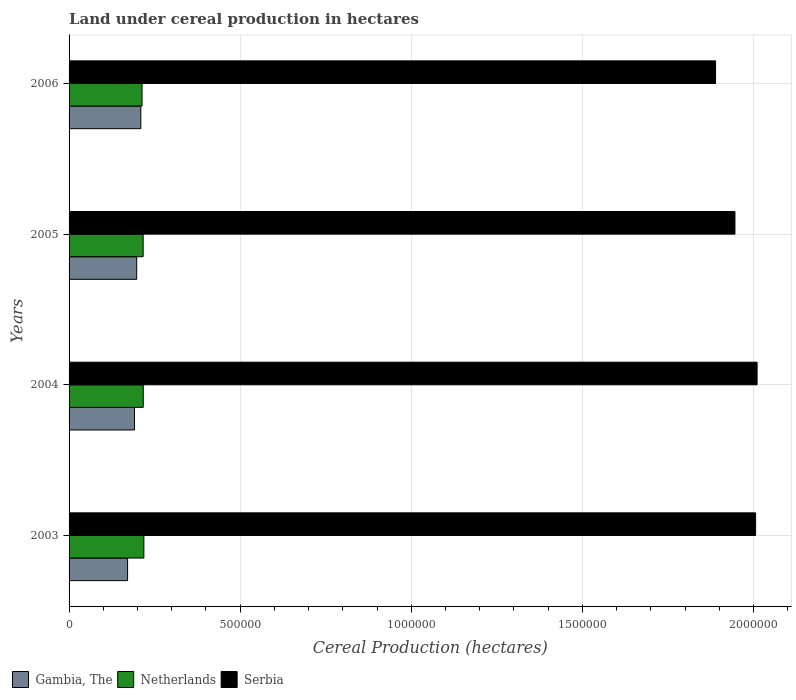Are the number of bars on each tick of the Y-axis equal?
Offer a terse response. Yes. What is the label of the 4th group of bars from the top?
Keep it short and to the point. 2003. What is the land under cereal production in Gambia, The in 2005?
Your response must be concise. 1.98e+05. Across all years, what is the maximum land under cereal production in Netherlands?
Offer a terse response. 2.19e+05. Across all years, what is the minimum land under cereal production in Gambia, The?
Your answer should be compact. 1.71e+05. In which year was the land under cereal production in Serbia maximum?
Offer a terse response. 2004. What is the total land under cereal production in Gambia, The in the graph?
Offer a very short reply. 7.70e+05. What is the difference between the land under cereal production in Netherlands in 2003 and that in 2006?
Ensure brevity in your answer.  5378. What is the difference between the land under cereal production in Netherlands in 2006 and the land under cereal production in Serbia in 2005?
Provide a succinct answer. -1.73e+06. What is the average land under cereal production in Serbia per year?
Give a very brief answer. 1.96e+06. In the year 2004, what is the difference between the land under cereal production in Netherlands and land under cereal production in Serbia?
Your answer should be very brief. -1.79e+06. What is the ratio of the land under cereal production in Gambia, The in 2003 to that in 2006?
Make the answer very short. 0.82. Is the land under cereal production in Serbia in 2003 less than that in 2005?
Keep it short and to the point. No. What is the difference between the highest and the second highest land under cereal production in Gambia, The?
Provide a short and direct response. 1.21e+04. What is the difference between the highest and the lowest land under cereal production in Gambia, The?
Ensure brevity in your answer.  3.88e+04. In how many years, is the land under cereal production in Netherlands greater than the average land under cereal production in Netherlands taken over all years?
Provide a short and direct response. 3. Is the sum of the land under cereal production in Netherlands in 2003 and 2005 greater than the maximum land under cereal production in Gambia, The across all years?
Keep it short and to the point. Yes. What does the 3rd bar from the top in 2005 represents?
Provide a succinct answer. Gambia, The. What does the 3rd bar from the bottom in 2006 represents?
Your response must be concise. Serbia. How many years are there in the graph?
Your answer should be very brief. 4. What is the difference between two consecutive major ticks on the X-axis?
Give a very brief answer. 5.00e+05. Does the graph contain grids?
Offer a terse response. Yes. Where does the legend appear in the graph?
Offer a very short reply. Bottom left. What is the title of the graph?
Provide a succinct answer. Land under cereal production in hectares. Does "Colombia" appear as one of the legend labels in the graph?
Keep it short and to the point. No. What is the label or title of the X-axis?
Ensure brevity in your answer.  Cereal Production (hectares). What is the Cereal Production (hectares) of Gambia, The in 2003?
Provide a short and direct response. 1.71e+05. What is the Cereal Production (hectares) of Netherlands in 2003?
Provide a short and direct response. 2.19e+05. What is the Cereal Production (hectares) of Serbia in 2003?
Provide a short and direct response. 2.01e+06. What is the Cereal Production (hectares) in Gambia, The in 2004?
Offer a terse response. 1.91e+05. What is the Cereal Production (hectares) of Netherlands in 2004?
Your answer should be compact. 2.17e+05. What is the Cereal Production (hectares) in Serbia in 2004?
Your answer should be compact. 2.01e+06. What is the Cereal Production (hectares) of Gambia, The in 2005?
Your answer should be compact. 1.98e+05. What is the Cereal Production (hectares) in Netherlands in 2005?
Provide a succinct answer. 2.16e+05. What is the Cereal Production (hectares) in Serbia in 2005?
Your answer should be compact. 1.95e+06. What is the Cereal Production (hectares) of Gambia, The in 2006?
Ensure brevity in your answer.  2.10e+05. What is the Cereal Production (hectares) of Netherlands in 2006?
Provide a short and direct response. 2.13e+05. What is the Cereal Production (hectares) in Serbia in 2006?
Provide a short and direct response. 1.89e+06. Across all years, what is the maximum Cereal Production (hectares) of Gambia, The?
Provide a succinct answer. 2.10e+05. Across all years, what is the maximum Cereal Production (hectares) in Netherlands?
Provide a succinct answer. 2.19e+05. Across all years, what is the maximum Cereal Production (hectares) in Serbia?
Keep it short and to the point. 2.01e+06. Across all years, what is the minimum Cereal Production (hectares) of Gambia, The?
Offer a terse response. 1.71e+05. Across all years, what is the minimum Cereal Production (hectares) of Netherlands?
Your answer should be very brief. 2.13e+05. Across all years, what is the minimum Cereal Production (hectares) in Serbia?
Your answer should be very brief. 1.89e+06. What is the total Cereal Production (hectares) in Gambia, The in the graph?
Your response must be concise. 7.70e+05. What is the total Cereal Production (hectares) in Netherlands in the graph?
Keep it short and to the point. 8.65e+05. What is the total Cereal Production (hectares) in Serbia in the graph?
Ensure brevity in your answer.  7.85e+06. What is the difference between the Cereal Production (hectares) of Gambia, The in 2003 and that in 2004?
Your response must be concise. -2.02e+04. What is the difference between the Cereal Production (hectares) of Netherlands in 2003 and that in 2004?
Your response must be concise. 1845. What is the difference between the Cereal Production (hectares) of Serbia in 2003 and that in 2004?
Offer a very short reply. -4339. What is the difference between the Cereal Production (hectares) in Gambia, The in 2003 and that in 2005?
Provide a succinct answer. -2.66e+04. What is the difference between the Cereal Production (hectares) of Netherlands in 2003 and that in 2005?
Ensure brevity in your answer.  2115. What is the difference between the Cereal Production (hectares) of Serbia in 2003 and that in 2005?
Give a very brief answer. 6.04e+04. What is the difference between the Cereal Production (hectares) of Gambia, The in 2003 and that in 2006?
Offer a terse response. -3.88e+04. What is the difference between the Cereal Production (hectares) in Netherlands in 2003 and that in 2006?
Keep it short and to the point. 5378. What is the difference between the Cereal Production (hectares) of Serbia in 2003 and that in 2006?
Ensure brevity in your answer.  1.17e+05. What is the difference between the Cereal Production (hectares) of Gambia, The in 2004 and that in 2005?
Offer a very short reply. -6404. What is the difference between the Cereal Production (hectares) in Netherlands in 2004 and that in 2005?
Give a very brief answer. 270. What is the difference between the Cereal Production (hectares) in Serbia in 2004 and that in 2005?
Your response must be concise. 6.47e+04. What is the difference between the Cereal Production (hectares) of Gambia, The in 2004 and that in 2006?
Keep it short and to the point. -1.85e+04. What is the difference between the Cereal Production (hectares) of Netherlands in 2004 and that in 2006?
Provide a short and direct response. 3533. What is the difference between the Cereal Production (hectares) in Serbia in 2004 and that in 2006?
Make the answer very short. 1.21e+05. What is the difference between the Cereal Production (hectares) in Gambia, The in 2005 and that in 2006?
Provide a succinct answer. -1.21e+04. What is the difference between the Cereal Production (hectares) of Netherlands in 2005 and that in 2006?
Offer a very short reply. 3263. What is the difference between the Cereal Production (hectares) in Serbia in 2005 and that in 2006?
Your response must be concise. 5.67e+04. What is the difference between the Cereal Production (hectares) of Gambia, The in 2003 and the Cereal Production (hectares) of Netherlands in 2004?
Your answer should be very brief. -4.58e+04. What is the difference between the Cereal Production (hectares) in Gambia, The in 2003 and the Cereal Production (hectares) in Serbia in 2004?
Your answer should be very brief. -1.84e+06. What is the difference between the Cereal Production (hectares) of Netherlands in 2003 and the Cereal Production (hectares) of Serbia in 2004?
Your answer should be very brief. -1.79e+06. What is the difference between the Cereal Production (hectares) in Gambia, The in 2003 and the Cereal Production (hectares) in Netherlands in 2005?
Your response must be concise. -4.55e+04. What is the difference between the Cereal Production (hectares) of Gambia, The in 2003 and the Cereal Production (hectares) of Serbia in 2005?
Keep it short and to the point. -1.77e+06. What is the difference between the Cereal Production (hectares) of Netherlands in 2003 and the Cereal Production (hectares) of Serbia in 2005?
Ensure brevity in your answer.  -1.73e+06. What is the difference between the Cereal Production (hectares) in Gambia, The in 2003 and the Cereal Production (hectares) in Netherlands in 2006?
Offer a very short reply. -4.23e+04. What is the difference between the Cereal Production (hectares) of Gambia, The in 2003 and the Cereal Production (hectares) of Serbia in 2006?
Your response must be concise. -1.72e+06. What is the difference between the Cereal Production (hectares) of Netherlands in 2003 and the Cereal Production (hectares) of Serbia in 2006?
Your answer should be compact. -1.67e+06. What is the difference between the Cereal Production (hectares) of Gambia, The in 2004 and the Cereal Production (hectares) of Netherlands in 2005?
Keep it short and to the point. -2.53e+04. What is the difference between the Cereal Production (hectares) in Gambia, The in 2004 and the Cereal Production (hectares) in Serbia in 2005?
Your response must be concise. -1.75e+06. What is the difference between the Cereal Production (hectares) of Netherlands in 2004 and the Cereal Production (hectares) of Serbia in 2005?
Make the answer very short. -1.73e+06. What is the difference between the Cereal Production (hectares) in Gambia, The in 2004 and the Cereal Production (hectares) in Netherlands in 2006?
Make the answer very short. -2.20e+04. What is the difference between the Cereal Production (hectares) of Gambia, The in 2004 and the Cereal Production (hectares) of Serbia in 2006?
Offer a very short reply. -1.70e+06. What is the difference between the Cereal Production (hectares) in Netherlands in 2004 and the Cereal Production (hectares) in Serbia in 2006?
Offer a very short reply. -1.67e+06. What is the difference between the Cereal Production (hectares) of Gambia, The in 2005 and the Cereal Production (hectares) of Netherlands in 2006?
Keep it short and to the point. -1.56e+04. What is the difference between the Cereal Production (hectares) in Gambia, The in 2005 and the Cereal Production (hectares) in Serbia in 2006?
Provide a short and direct response. -1.69e+06. What is the difference between the Cereal Production (hectares) of Netherlands in 2005 and the Cereal Production (hectares) of Serbia in 2006?
Your answer should be very brief. -1.67e+06. What is the average Cereal Production (hectares) of Gambia, The per year?
Give a very brief answer. 1.92e+05. What is the average Cereal Production (hectares) in Netherlands per year?
Your answer should be very brief. 2.16e+05. What is the average Cereal Production (hectares) in Serbia per year?
Provide a short and direct response. 1.96e+06. In the year 2003, what is the difference between the Cereal Production (hectares) in Gambia, The and Cereal Production (hectares) in Netherlands?
Your response must be concise. -4.76e+04. In the year 2003, what is the difference between the Cereal Production (hectares) of Gambia, The and Cereal Production (hectares) of Serbia?
Provide a short and direct response. -1.84e+06. In the year 2003, what is the difference between the Cereal Production (hectares) of Netherlands and Cereal Production (hectares) of Serbia?
Offer a terse response. -1.79e+06. In the year 2004, what is the difference between the Cereal Production (hectares) of Gambia, The and Cereal Production (hectares) of Netherlands?
Your response must be concise. -2.56e+04. In the year 2004, what is the difference between the Cereal Production (hectares) of Gambia, The and Cereal Production (hectares) of Serbia?
Ensure brevity in your answer.  -1.82e+06. In the year 2004, what is the difference between the Cereal Production (hectares) in Netherlands and Cereal Production (hectares) in Serbia?
Offer a terse response. -1.79e+06. In the year 2005, what is the difference between the Cereal Production (hectares) of Gambia, The and Cereal Production (hectares) of Netherlands?
Ensure brevity in your answer.  -1.89e+04. In the year 2005, what is the difference between the Cereal Production (hectares) in Gambia, The and Cereal Production (hectares) in Serbia?
Offer a terse response. -1.75e+06. In the year 2005, what is the difference between the Cereal Production (hectares) in Netherlands and Cereal Production (hectares) in Serbia?
Make the answer very short. -1.73e+06. In the year 2006, what is the difference between the Cereal Production (hectares) in Gambia, The and Cereal Production (hectares) in Netherlands?
Offer a very short reply. -3489. In the year 2006, what is the difference between the Cereal Production (hectares) of Gambia, The and Cereal Production (hectares) of Serbia?
Offer a very short reply. -1.68e+06. In the year 2006, what is the difference between the Cereal Production (hectares) of Netherlands and Cereal Production (hectares) of Serbia?
Provide a succinct answer. -1.68e+06. What is the ratio of the Cereal Production (hectares) in Gambia, The in 2003 to that in 2004?
Your answer should be compact. 0.89. What is the ratio of the Cereal Production (hectares) in Netherlands in 2003 to that in 2004?
Your answer should be very brief. 1.01. What is the ratio of the Cereal Production (hectares) in Gambia, The in 2003 to that in 2005?
Your answer should be very brief. 0.87. What is the ratio of the Cereal Production (hectares) of Netherlands in 2003 to that in 2005?
Offer a very short reply. 1.01. What is the ratio of the Cereal Production (hectares) of Serbia in 2003 to that in 2005?
Offer a very short reply. 1.03. What is the ratio of the Cereal Production (hectares) in Gambia, The in 2003 to that in 2006?
Give a very brief answer. 0.82. What is the ratio of the Cereal Production (hectares) of Netherlands in 2003 to that in 2006?
Give a very brief answer. 1.03. What is the ratio of the Cereal Production (hectares) of Serbia in 2003 to that in 2006?
Make the answer very short. 1.06. What is the ratio of the Cereal Production (hectares) of Gambia, The in 2004 to that in 2005?
Give a very brief answer. 0.97. What is the ratio of the Cereal Production (hectares) in Gambia, The in 2004 to that in 2006?
Your answer should be compact. 0.91. What is the ratio of the Cereal Production (hectares) of Netherlands in 2004 to that in 2006?
Offer a terse response. 1.02. What is the ratio of the Cereal Production (hectares) of Serbia in 2004 to that in 2006?
Provide a short and direct response. 1.06. What is the ratio of the Cereal Production (hectares) in Gambia, The in 2005 to that in 2006?
Provide a succinct answer. 0.94. What is the ratio of the Cereal Production (hectares) of Netherlands in 2005 to that in 2006?
Your response must be concise. 1.02. What is the ratio of the Cereal Production (hectares) in Serbia in 2005 to that in 2006?
Your answer should be compact. 1.03. What is the difference between the highest and the second highest Cereal Production (hectares) in Gambia, The?
Provide a short and direct response. 1.21e+04. What is the difference between the highest and the second highest Cereal Production (hectares) of Netherlands?
Keep it short and to the point. 1845. What is the difference between the highest and the second highest Cereal Production (hectares) in Serbia?
Offer a very short reply. 4339. What is the difference between the highest and the lowest Cereal Production (hectares) in Gambia, The?
Ensure brevity in your answer.  3.88e+04. What is the difference between the highest and the lowest Cereal Production (hectares) of Netherlands?
Your answer should be compact. 5378. What is the difference between the highest and the lowest Cereal Production (hectares) in Serbia?
Make the answer very short. 1.21e+05. 